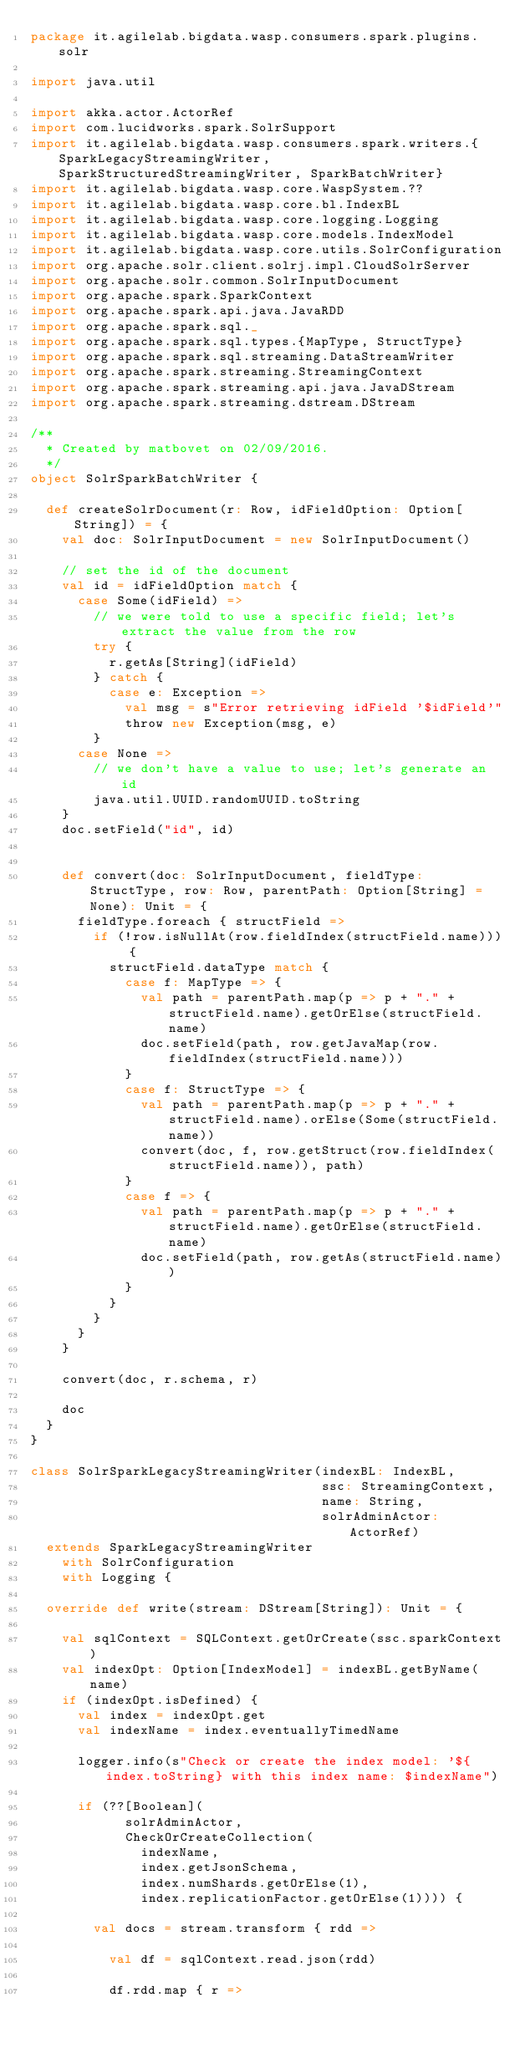<code> <loc_0><loc_0><loc_500><loc_500><_Scala_>package it.agilelab.bigdata.wasp.consumers.spark.plugins.solr

import java.util

import akka.actor.ActorRef
import com.lucidworks.spark.SolrSupport
import it.agilelab.bigdata.wasp.consumers.spark.writers.{SparkLegacyStreamingWriter, SparkStructuredStreamingWriter, SparkBatchWriter}
import it.agilelab.bigdata.wasp.core.WaspSystem.??
import it.agilelab.bigdata.wasp.core.bl.IndexBL
import it.agilelab.bigdata.wasp.core.logging.Logging
import it.agilelab.bigdata.wasp.core.models.IndexModel
import it.agilelab.bigdata.wasp.core.utils.SolrConfiguration
import org.apache.solr.client.solrj.impl.CloudSolrServer
import org.apache.solr.common.SolrInputDocument
import org.apache.spark.SparkContext
import org.apache.spark.api.java.JavaRDD
import org.apache.spark.sql._
import org.apache.spark.sql.types.{MapType, StructType}
import org.apache.spark.sql.streaming.DataStreamWriter
import org.apache.spark.streaming.StreamingContext
import org.apache.spark.streaming.api.java.JavaDStream
import org.apache.spark.streaming.dstream.DStream

/**
  * Created by matbovet on 02/09/2016.
  */
object SolrSparkBatchWriter {

  def createSolrDocument(r: Row, idFieldOption: Option[String]) = {
    val doc: SolrInputDocument = new SolrInputDocument()

    // set the id of the document
    val id = idFieldOption match {
      case Some(idField) =>
        // we were told to use a specific field; let's extract the value from the row
        try {
          r.getAs[String](idField)
        } catch {
          case e: Exception =>
            val msg = s"Error retrieving idField '$idField'"
            throw new Exception(msg, e)
        }
      case None =>
        // we don't have a value to use; let's generate an id
        java.util.UUID.randomUUID.toString
    }
    doc.setField("id", id)


    def convert(doc: SolrInputDocument, fieldType: StructType, row: Row, parentPath: Option[String] = None): Unit = {
      fieldType.foreach { structField =>
        if (!row.isNullAt(row.fieldIndex(structField.name))) {
          structField.dataType match {
            case f: MapType => {
              val path = parentPath.map(p => p + "." + structField.name).getOrElse(structField.name)
              doc.setField(path, row.getJavaMap(row.fieldIndex(structField.name)))
            }
            case f: StructType => {
              val path = parentPath.map(p => p + "." + structField.name).orElse(Some(structField.name))
              convert(doc, f, row.getStruct(row.fieldIndex(structField.name)), path)
            }
            case f => {
              val path = parentPath.map(p => p + "." + structField.name).getOrElse(structField.name)
              doc.setField(path, row.getAs(structField.name))
            }
          }
        }
      }
    }

    convert(doc, r.schema, r)

    doc
  }
}

class SolrSparkLegacyStreamingWriter(indexBL: IndexBL,
                                     ssc: StreamingContext,
                                     name: String,
                                     solrAdminActor: ActorRef)
  extends SparkLegacyStreamingWriter
    with SolrConfiguration
    with Logging {

  override def write(stream: DStream[String]): Unit = {

    val sqlContext = SQLContext.getOrCreate(ssc.sparkContext)
    val indexOpt: Option[IndexModel] = indexBL.getByName(name)
    if (indexOpt.isDefined) {
      val index = indexOpt.get
      val indexName = index.eventuallyTimedName

      logger.info(s"Check or create the index model: '${index.toString} with this index name: $indexName")

      if (??[Boolean](
            solrAdminActor,
            CheckOrCreateCollection(
              indexName,
              index.getJsonSchema,
              index.numShards.getOrElse(1),
              index.replicationFactor.getOrElse(1)))) {

        val docs = stream.transform { rdd =>

          val df = sqlContext.read.json(rdd)

          df.rdd.map { r =></code> 